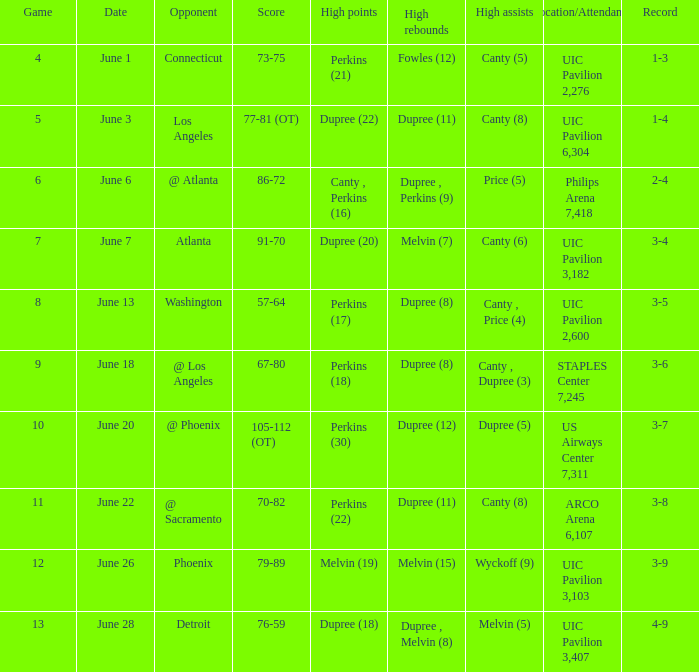What's the scheduled date for the ninth game? June 18. 